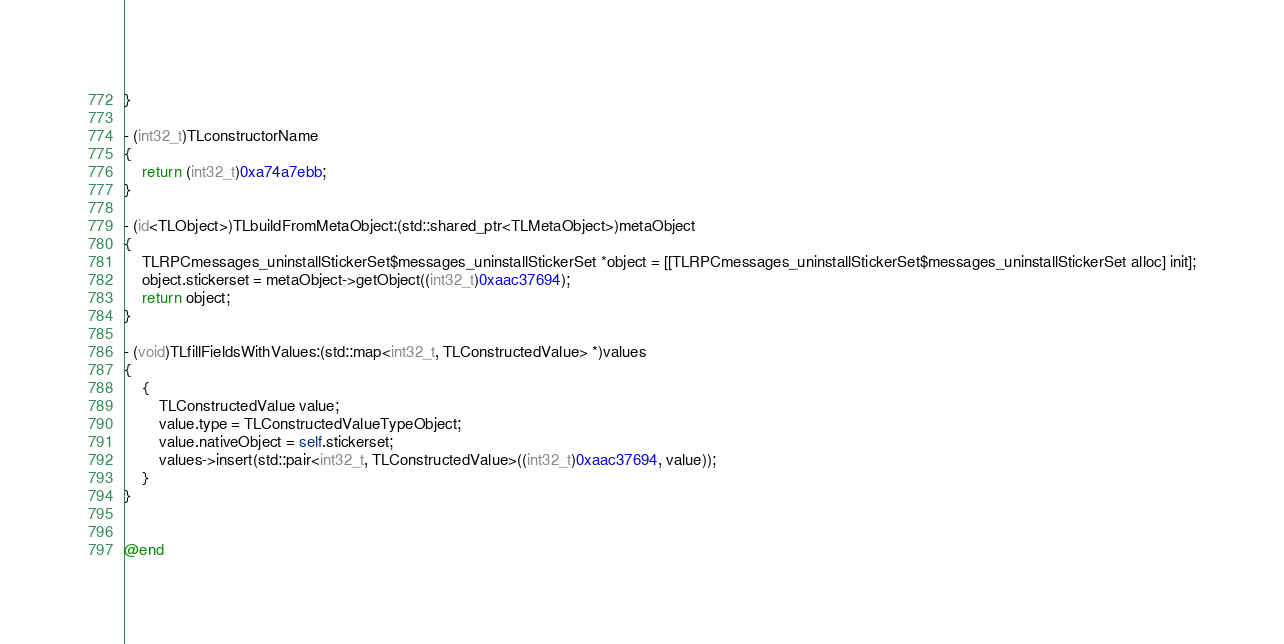Convert code to text. <code><loc_0><loc_0><loc_500><loc_500><_ObjectiveC_>}

- (int32_t)TLconstructorName
{
    return (int32_t)0xa74a7ebb;
}

- (id<TLObject>)TLbuildFromMetaObject:(std::shared_ptr<TLMetaObject>)metaObject
{
    TLRPCmessages_uninstallStickerSet$messages_uninstallStickerSet *object = [[TLRPCmessages_uninstallStickerSet$messages_uninstallStickerSet alloc] init];
    object.stickerset = metaObject->getObject((int32_t)0xaac37694);
    return object;
}

- (void)TLfillFieldsWithValues:(std::map<int32_t, TLConstructedValue> *)values
{
    {
        TLConstructedValue value;
        value.type = TLConstructedValueTypeObject;
        value.nativeObject = self.stickerset;
        values->insert(std::pair<int32_t, TLConstructedValue>((int32_t)0xaac37694, value));
    }
}


@end

</code> 